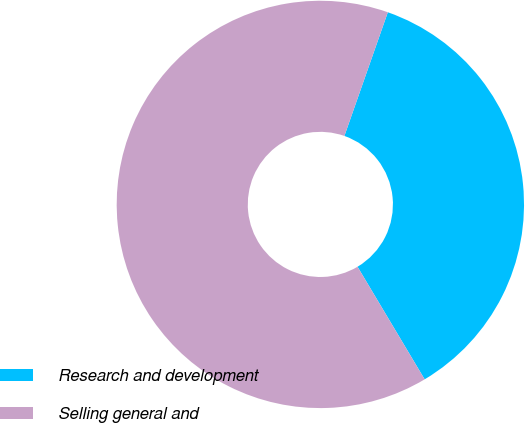Convert chart. <chart><loc_0><loc_0><loc_500><loc_500><pie_chart><fcel>Research and development<fcel>Selling general and<nl><fcel>36.07%<fcel>63.93%<nl></chart> 